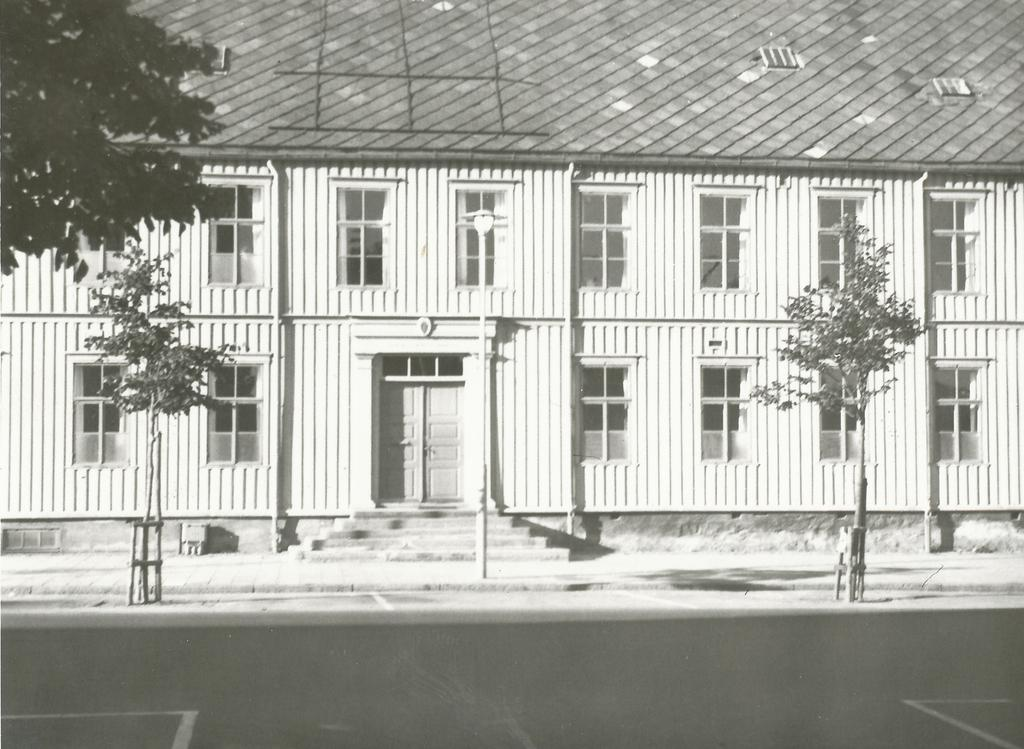What is the color scheme of the image? The image is black and white. What structure can be seen in the background of the image? There is a house in the background of the image. What features can be observed on the house? The house has windows and a door. What type of vegetation is visible in the background of the image? There are trees in the background of the image. What is located at the bottom of the image? There is a road at the bottom of the image. How many teeth can be seen in the image? There are no teeth visible in the image. What type of cow is present in the image? There is no cow present in the image. 